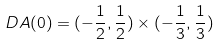Convert formula to latex. <formula><loc_0><loc_0><loc_500><loc_500>D A ( 0 ) = ( - \frac { 1 } { 2 } , \frac { 1 } { 2 } ) \times ( - \frac { 1 } { 3 } , \frac { 1 } { 3 } )</formula> 